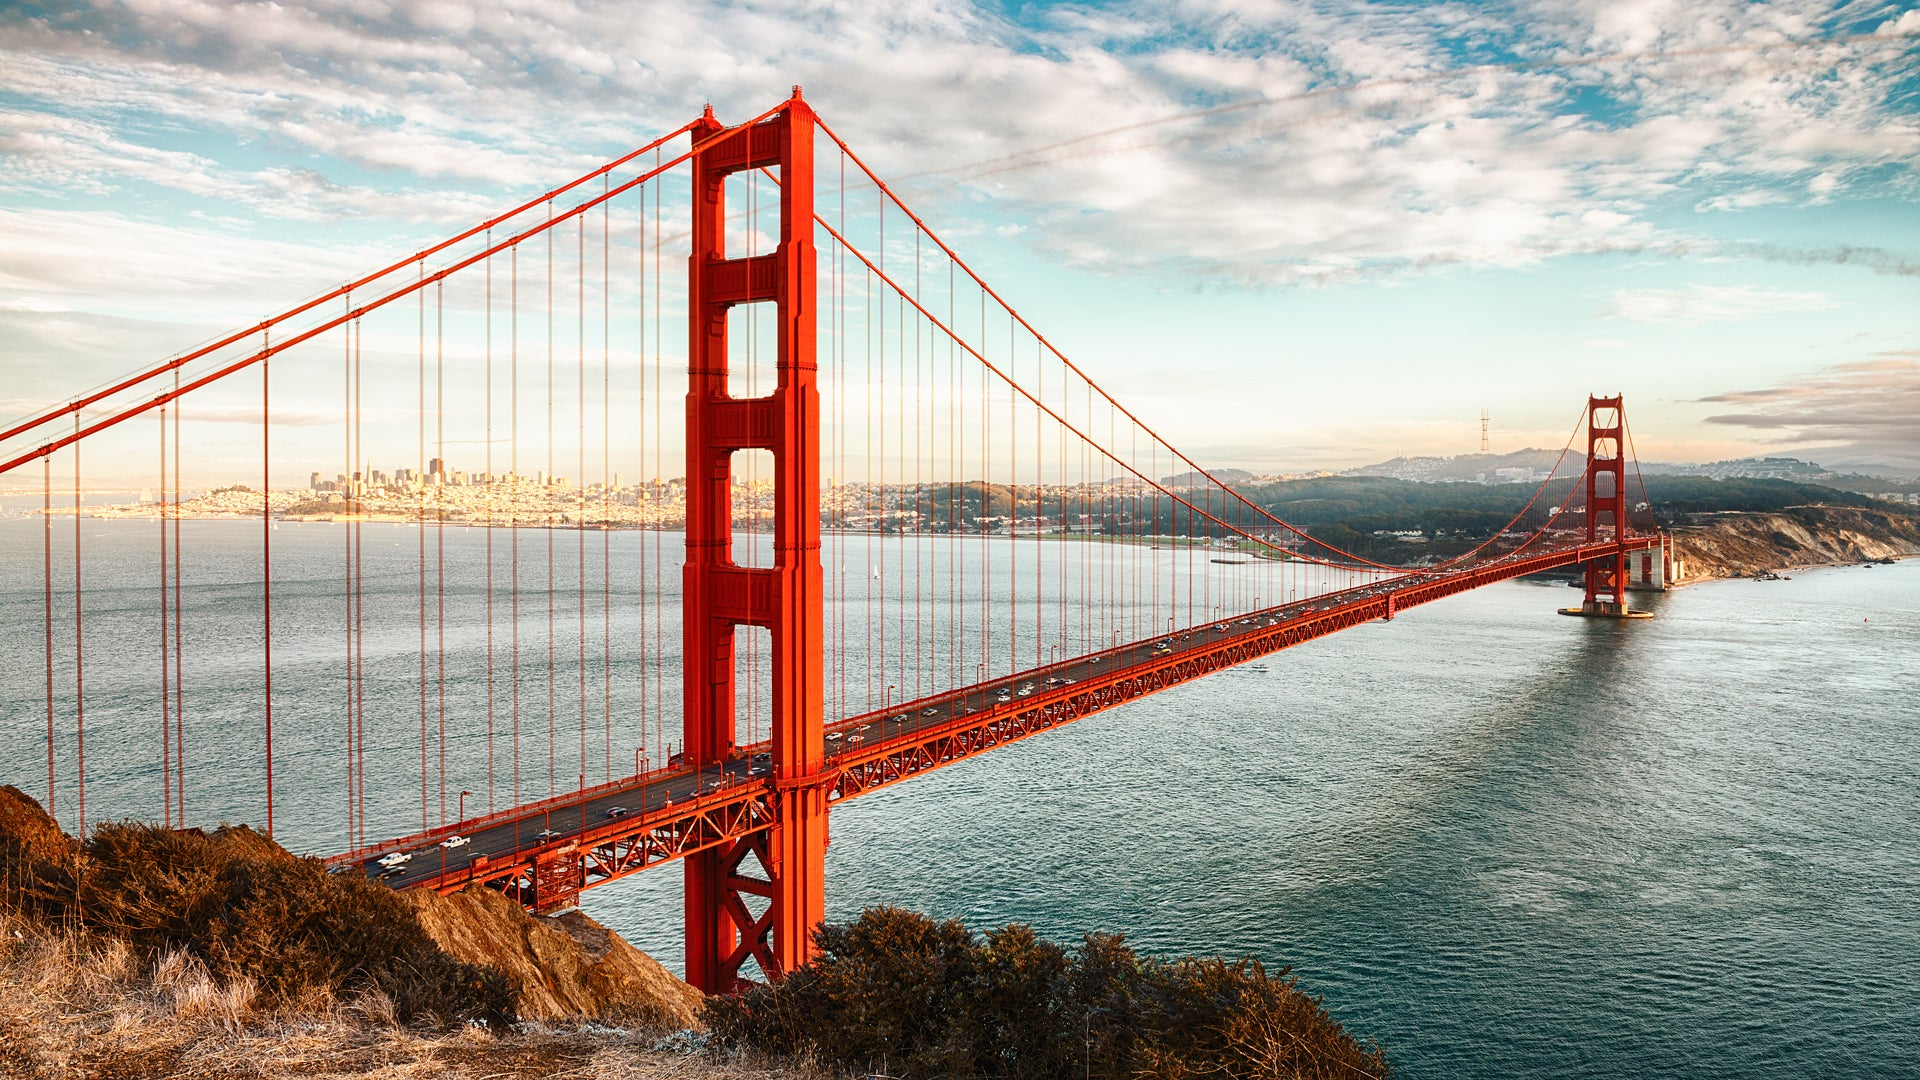Imagine a fantastical scenario taking place on the bridge. Describe it in detail. As the sun begins to set, casting a golden hue over the scene, the Golden Gate Bridge transforms into a gateway to another world. Ethereal lights begin to twinkle along its length, and suddenly, mystical creatures emerge from the bridge's towering pillars. Enormous dragons with shimmering scales take flight, their wings creating a gentle breeze that ripples the water below. Fairies with incandescent wings flit about, sprinkling magical dust that makes the entire bridge glow with an otherworldly luminescence. Below, the water churns as majestic sea serpents surface, their eyes sparkling with intelligence. The air is filled with the soft sound of ancient melodies as this magical procession continues, drawing spectators from both realms—the human onlookers from the city skyline and curious beings from fantastical realms beyond. The bridge now serves as a magnificent conduit between worlds, a place where the boundaries of reality and imagination blur harmoniously. 